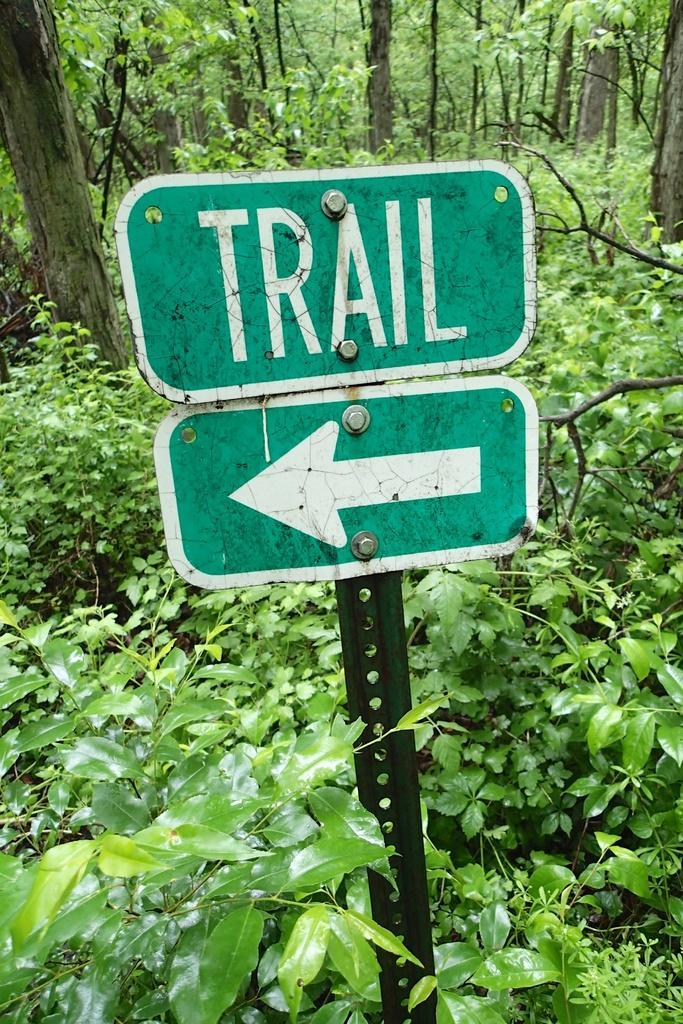Could you give a brief overview of what you see in this image? In this picture I can observe two boards fixed to the pole in the middle of the picture. In the background I can observe trees and plants on the ground. 